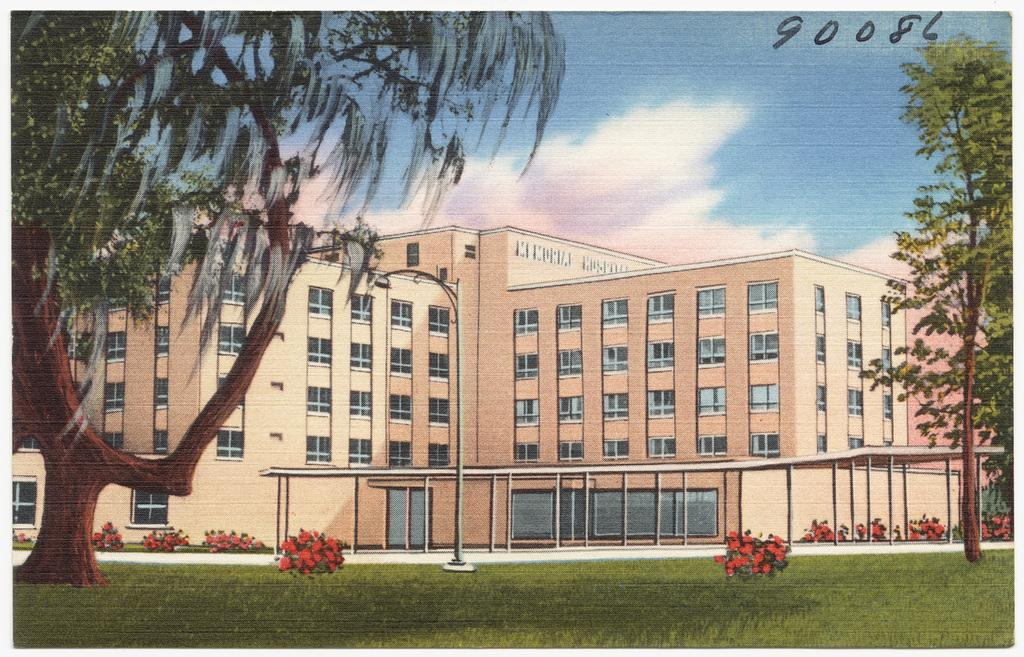What subjects are depicted in the paintings in the image? There is a painting of a building, a painting of a tree, a painting of grass, a painting of flowers, a painting of the sky, and a painting of clouds. How does the painting of the building engage in a conversation with the painting of the tree? Paintings cannot engage in conversations, as they are inanimate objects. What type of tail can be seen on the painting of the building? There is no tail present on the painting of the building, as it is a painting of a building and not a living creature. 